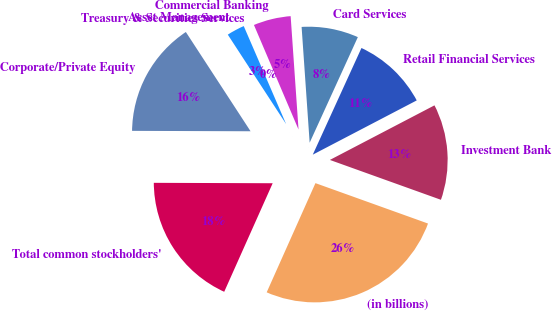Convert chart. <chart><loc_0><loc_0><loc_500><loc_500><pie_chart><fcel>(in billions)<fcel>Investment Bank<fcel>Retail Financial Services<fcel>Card Services<fcel>Commercial Banking<fcel>Treasury & Securities Services<fcel>Asset Management<fcel>Corporate/Private Equity<fcel>Total common stockholders'<nl><fcel>26.2%<fcel>13.14%<fcel>10.53%<fcel>7.92%<fcel>5.31%<fcel>0.08%<fcel>2.7%<fcel>15.75%<fcel>18.37%<nl></chart> 